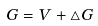<formula> <loc_0><loc_0><loc_500><loc_500>G = V + \triangle G</formula> 